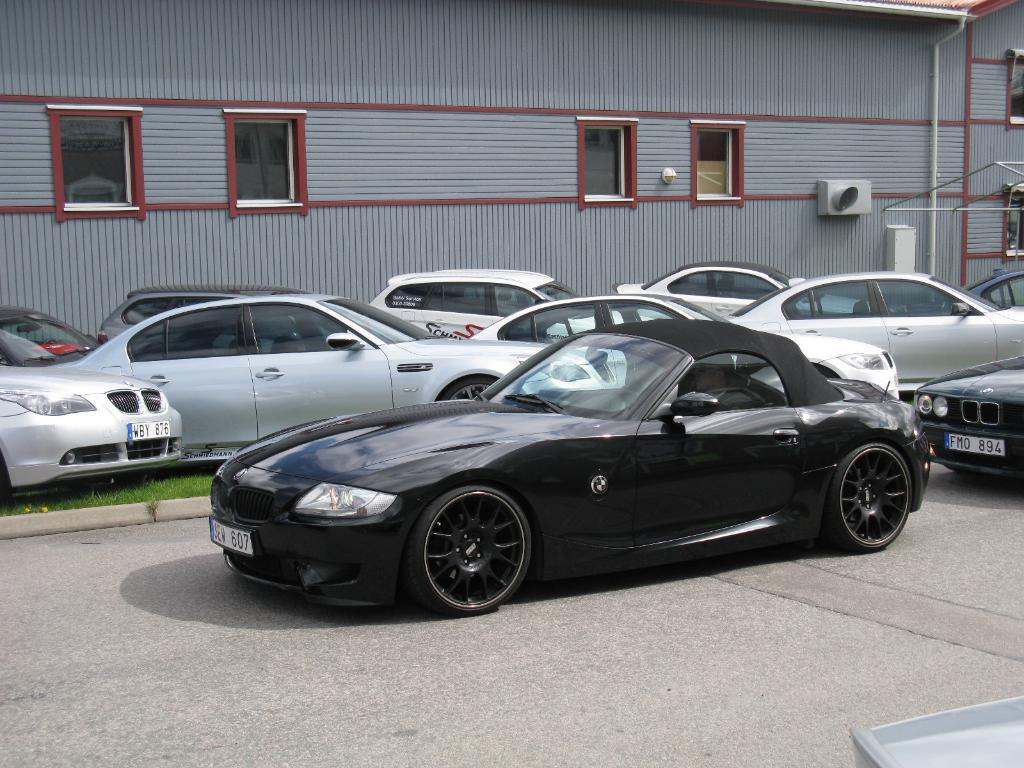What is the main subject in the center of the image? There are cars in the center of the image. What is the setting of the image? There is a road in the image. What can be seen in the background of the image? There is a building in the background of the image. What feature of the building is mentioned in the facts? There are windows in the building. What type of meat is being served at the party in the image? There is no party or meat present in the image; it features cars on a road with a building in the background. 